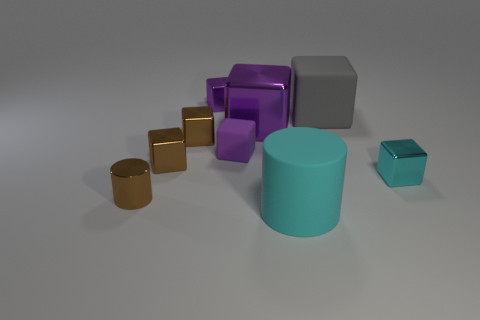How many tiny things are both on the right side of the brown cylinder and on the left side of the cyan shiny block?
Offer a terse response. 4. Do the shiny block that is right of the gray cube and the matte cube that is right of the large purple thing have the same size?
Keep it short and to the point. No. What number of things are either objects in front of the small brown metallic cylinder or tiny cubes?
Keep it short and to the point. 6. There is a large thing in front of the tiny rubber thing; what is it made of?
Make the answer very short. Rubber. What is the material of the big cylinder?
Your answer should be compact. Rubber. The cyan object in front of the brown shiny cylinder that is in front of the purple metallic cube that is to the right of the small purple metallic object is made of what material?
Your answer should be compact. Rubber. There is a brown cylinder; is its size the same as the rubber block that is right of the rubber cylinder?
Keep it short and to the point. No. What number of things are either small cubes on the left side of the gray rubber block or small shiny objects left of the purple rubber thing?
Your answer should be very brief. 5. What is the color of the large object in front of the small purple rubber object?
Offer a very short reply. Cyan. There is a cyan matte cylinder that is in front of the purple rubber cube; is there a small purple shiny object behind it?
Offer a very short reply. Yes. 